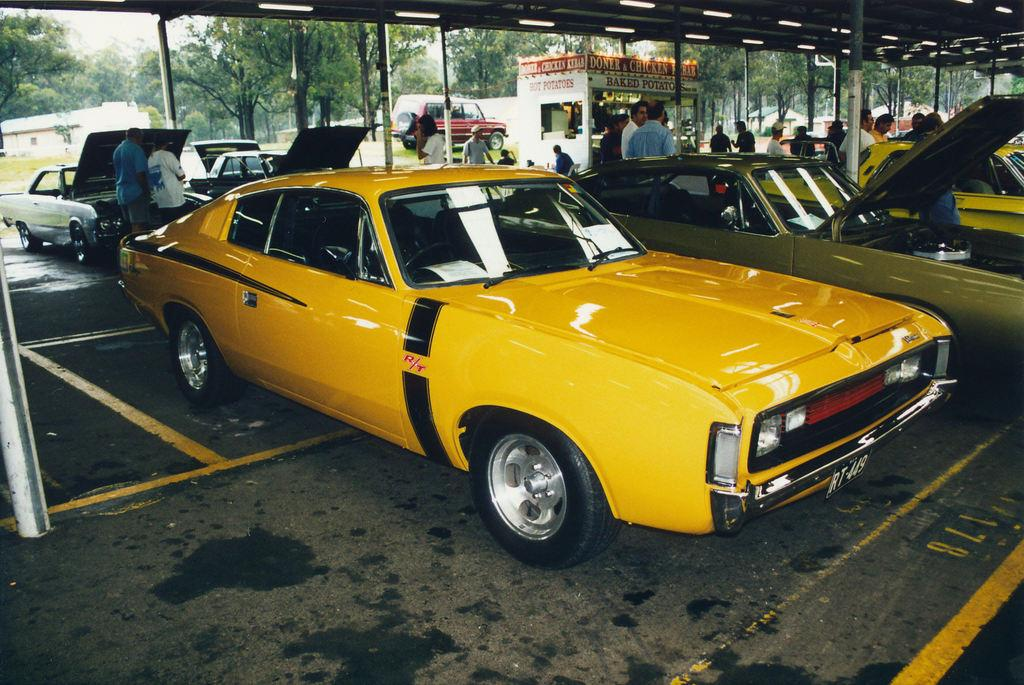<image>
Describe the image concisely. A yellow sports car with a black stripe and the letters R/T in red parked next to a few more sports cars. 